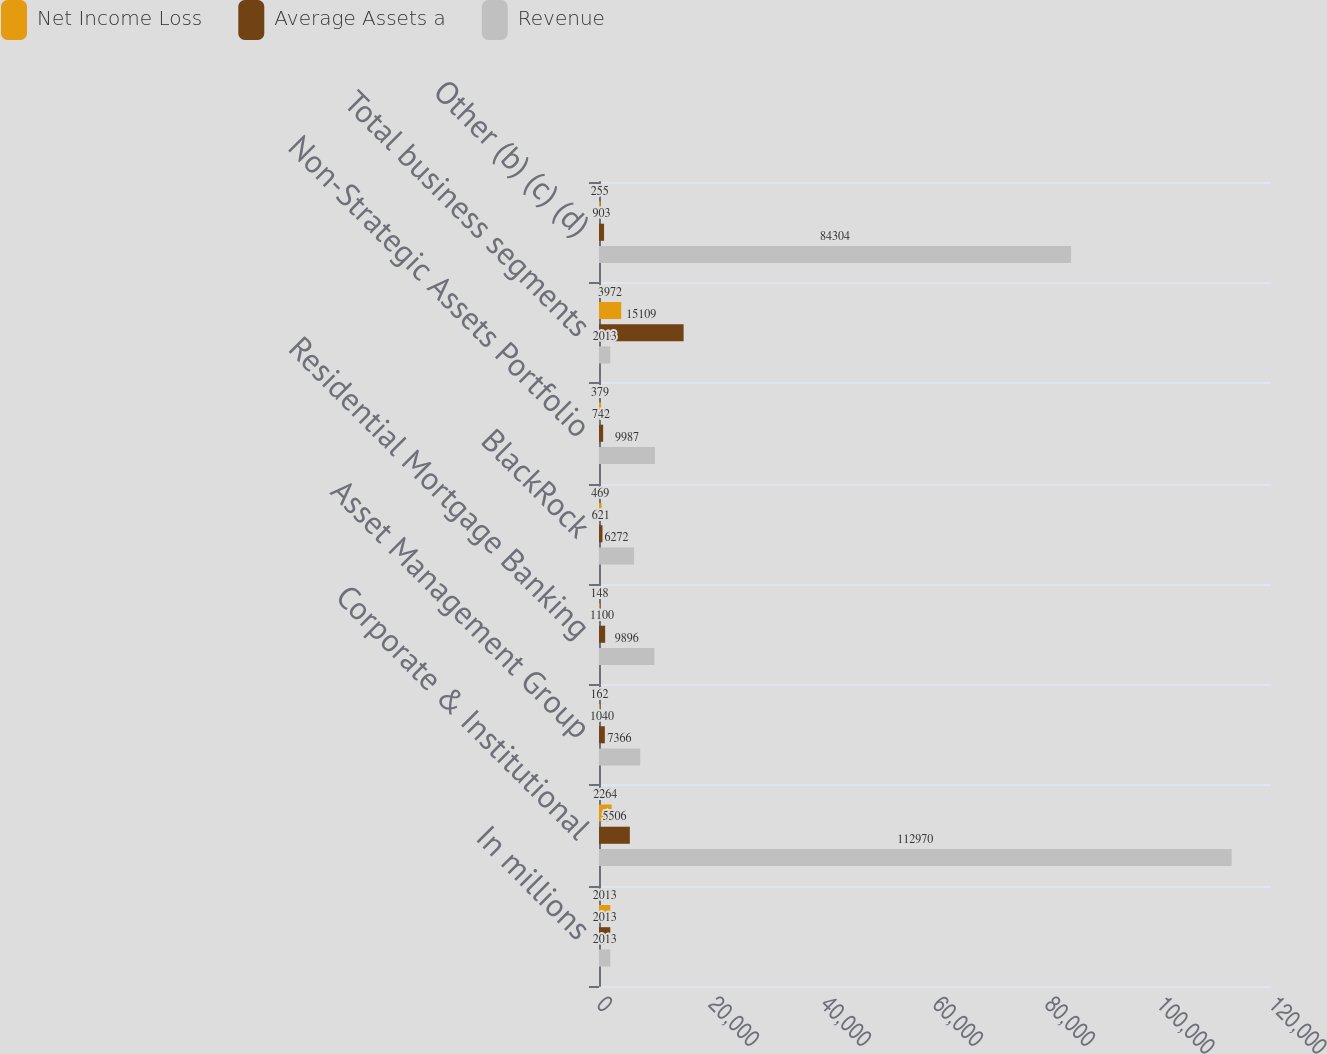Convert chart. <chart><loc_0><loc_0><loc_500><loc_500><stacked_bar_chart><ecel><fcel>In millions<fcel>Corporate & Institutional<fcel>Asset Management Group<fcel>Residential Mortgage Banking<fcel>BlackRock<fcel>Non-Strategic Assets Portfolio<fcel>Total business segments<fcel>Other (b) (c) (d)<nl><fcel>Net Income Loss<fcel>2013<fcel>2264<fcel>162<fcel>148<fcel>469<fcel>379<fcel>3972<fcel>255<nl><fcel>Average Assets a<fcel>2013<fcel>5506<fcel>1040<fcel>1100<fcel>621<fcel>742<fcel>15109<fcel>903<nl><fcel>Revenue<fcel>2013<fcel>112970<fcel>7366<fcel>9896<fcel>6272<fcel>9987<fcel>2013<fcel>84304<nl></chart> 